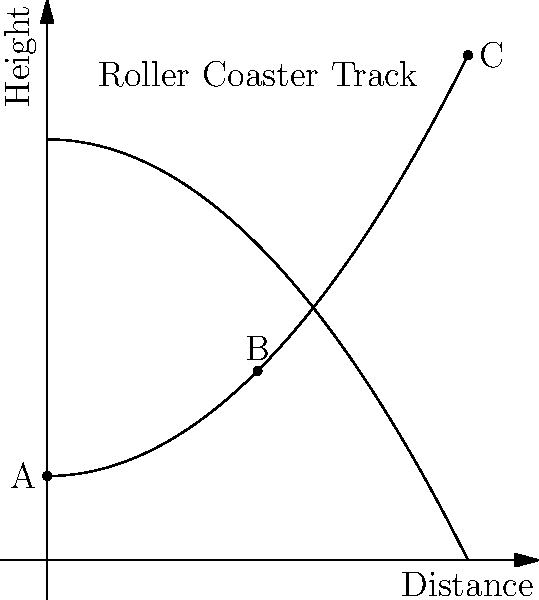A roller coaster starts at point A, reaches its highest point at C, and has a midpoint at B. If the total energy of the system remains constant, at which point does the roller coaster have the highest kinetic energy? Let's approach this step-by-step:

1. Recall that total energy in a closed system is conserved. In this case:
   $$ \text{Total Energy} = \text{Potential Energy (PE)} + \text{Kinetic Energy (KE)} = \text{Constant} $$

2. Potential energy depends on height. The higher an object is, the more potential energy it has.
   $$ \text{PE} = mgh $$
   where $m$ is mass, $g$ is gravitational acceleration, and $h$ is height.

3. Kinetic energy depends on velocity. The faster an object moves, the more kinetic energy it has.
   $$ \text{KE} = \frac{1}{2}mv^2 $$
   where $m$ is mass and $v$ is velocity.

4. Looking at the diagram:
   - Point A: Low height, starting point (likely low velocity)
   - Point B: Medium height
   - Point C: Highest point

5. At the highest point (C), the roller coaster has maximum potential energy but minimum velocity (it slows down as it reaches the top).

6. At the lowest point (A), the roller coaster has minimum potential energy but is likely not at maximum velocity as it's just starting.

7. At point B, the roller coaster has converted some of its initial potential energy into kinetic energy, but hasn't reached the lowest point yet.

8. Given that total energy is constant, when potential energy is lowest, kinetic energy must be highest to maintain the energy balance.

9. Therefore, the roller coaster will have the highest kinetic energy at its lowest point, which is point A.
Answer: Point A 